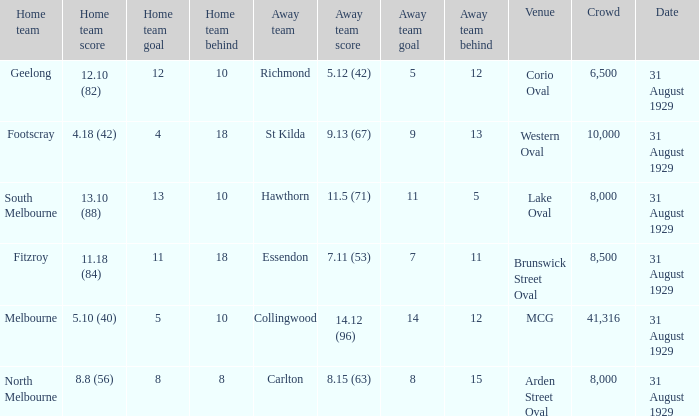What was the score of the home team when the away team scored 14.12 (96)? 5.10 (40). 